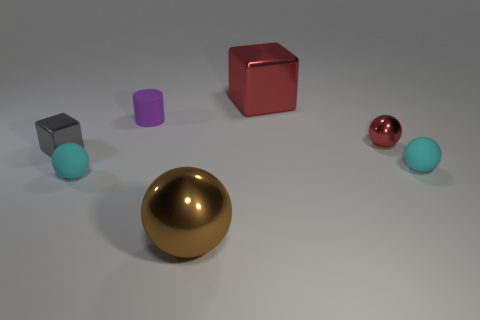Add 1 rubber objects. How many objects exist? 8 Subtract all green balls. Subtract all gray blocks. How many balls are left? 4 Subtract all cubes. How many objects are left? 5 Subtract 0 cyan blocks. How many objects are left? 7 Subtract all small red metallic objects. Subtract all tiny yellow metallic cylinders. How many objects are left? 6 Add 5 tiny spheres. How many tiny spheres are left? 8 Add 1 tiny yellow rubber cubes. How many tiny yellow rubber cubes exist? 1 